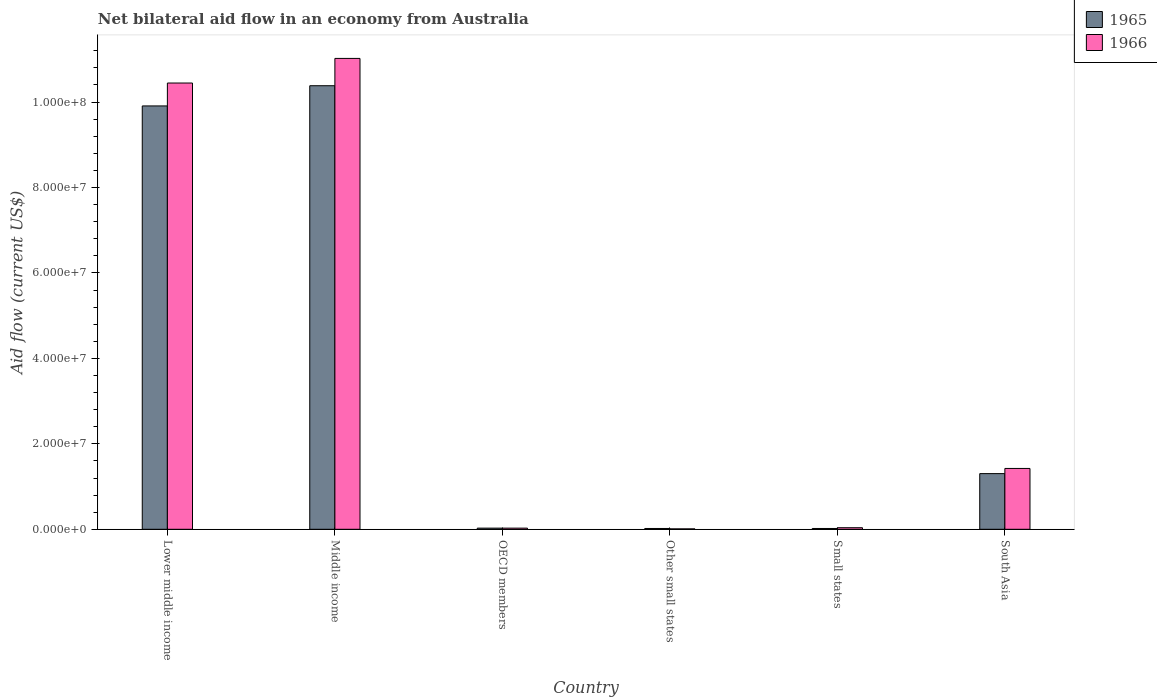How many different coloured bars are there?
Your answer should be compact. 2. How many groups of bars are there?
Provide a short and direct response. 6. Are the number of bars per tick equal to the number of legend labels?
Make the answer very short. Yes. Are the number of bars on each tick of the X-axis equal?
Offer a terse response. Yes. How many bars are there on the 1st tick from the left?
Your answer should be very brief. 2. What is the label of the 3rd group of bars from the left?
Keep it short and to the point. OECD members. What is the net bilateral aid flow in 1965 in Middle income?
Make the answer very short. 1.04e+08. Across all countries, what is the maximum net bilateral aid flow in 1965?
Your response must be concise. 1.04e+08. In which country was the net bilateral aid flow in 1965 minimum?
Provide a succinct answer. Other small states. What is the total net bilateral aid flow in 1966 in the graph?
Make the answer very short. 2.30e+08. What is the difference between the net bilateral aid flow in 1966 in Middle income and the net bilateral aid flow in 1965 in OECD members?
Make the answer very short. 1.10e+08. What is the average net bilateral aid flow in 1966 per country?
Your answer should be compact. 3.83e+07. In how many countries, is the net bilateral aid flow in 1965 greater than 44000000 US$?
Ensure brevity in your answer.  2. What is the ratio of the net bilateral aid flow in 1966 in Lower middle income to that in South Asia?
Your answer should be compact. 7.33. Is the net bilateral aid flow in 1966 in Small states less than that in South Asia?
Ensure brevity in your answer.  Yes. What is the difference between the highest and the second highest net bilateral aid flow in 1965?
Your answer should be very brief. 4.73e+06. What is the difference between the highest and the lowest net bilateral aid flow in 1965?
Offer a very short reply. 1.04e+08. Is the sum of the net bilateral aid flow in 1966 in Middle income and Other small states greater than the maximum net bilateral aid flow in 1965 across all countries?
Your answer should be very brief. Yes. What does the 1st bar from the left in Middle income represents?
Your answer should be compact. 1965. What does the 2nd bar from the right in OECD members represents?
Your response must be concise. 1965. How many bars are there?
Ensure brevity in your answer.  12. Are the values on the major ticks of Y-axis written in scientific E-notation?
Give a very brief answer. Yes. Does the graph contain any zero values?
Make the answer very short. No. Does the graph contain grids?
Your answer should be compact. No. How many legend labels are there?
Your answer should be compact. 2. What is the title of the graph?
Offer a terse response. Net bilateral aid flow in an economy from Australia. Does "1974" appear as one of the legend labels in the graph?
Keep it short and to the point. No. What is the label or title of the X-axis?
Your answer should be very brief. Country. What is the label or title of the Y-axis?
Your response must be concise. Aid flow (current US$). What is the Aid flow (current US$) of 1965 in Lower middle income?
Your answer should be very brief. 9.91e+07. What is the Aid flow (current US$) in 1966 in Lower middle income?
Offer a very short reply. 1.04e+08. What is the Aid flow (current US$) in 1965 in Middle income?
Offer a terse response. 1.04e+08. What is the Aid flow (current US$) of 1966 in Middle income?
Give a very brief answer. 1.10e+08. What is the Aid flow (current US$) of 1965 in Other small states?
Offer a terse response. 1.90e+05. What is the Aid flow (current US$) of 1965 in Small states?
Offer a very short reply. 1.90e+05. What is the Aid flow (current US$) of 1965 in South Asia?
Your response must be concise. 1.30e+07. What is the Aid flow (current US$) in 1966 in South Asia?
Provide a succinct answer. 1.42e+07. Across all countries, what is the maximum Aid flow (current US$) of 1965?
Ensure brevity in your answer.  1.04e+08. Across all countries, what is the maximum Aid flow (current US$) in 1966?
Offer a very short reply. 1.10e+08. What is the total Aid flow (current US$) in 1965 in the graph?
Provide a succinct answer. 2.17e+08. What is the total Aid flow (current US$) in 1966 in the graph?
Ensure brevity in your answer.  2.30e+08. What is the difference between the Aid flow (current US$) in 1965 in Lower middle income and that in Middle income?
Keep it short and to the point. -4.73e+06. What is the difference between the Aid flow (current US$) in 1966 in Lower middle income and that in Middle income?
Offer a terse response. -5.76e+06. What is the difference between the Aid flow (current US$) in 1965 in Lower middle income and that in OECD members?
Ensure brevity in your answer.  9.88e+07. What is the difference between the Aid flow (current US$) of 1966 in Lower middle income and that in OECD members?
Give a very brief answer. 1.04e+08. What is the difference between the Aid flow (current US$) in 1965 in Lower middle income and that in Other small states?
Provide a succinct answer. 9.89e+07. What is the difference between the Aid flow (current US$) of 1966 in Lower middle income and that in Other small states?
Provide a short and direct response. 1.04e+08. What is the difference between the Aid flow (current US$) in 1965 in Lower middle income and that in Small states?
Offer a terse response. 9.89e+07. What is the difference between the Aid flow (current US$) of 1966 in Lower middle income and that in Small states?
Keep it short and to the point. 1.04e+08. What is the difference between the Aid flow (current US$) of 1965 in Lower middle income and that in South Asia?
Offer a very short reply. 8.61e+07. What is the difference between the Aid flow (current US$) of 1966 in Lower middle income and that in South Asia?
Your response must be concise. 9.02e+07. What is the difference between the Aid flow (current US$) of 1965 in Middle income and that in OECD members?
Your answer should be very brief. 1.04e+08. What is the difference between the Aid flow (current US$) of 1966 in Middle income and that in OECD members?
Offer a terse response. 1.10e+08. What is the difference between the Aid flow (current US$) in 1965 in Middle income and that in Other small states?
Your answer should be compact. 1.04e+08. What is the difference between the Aid flow (current US$) of 1966 in Middle income and that in Other small states?
Provide a succinct answer. 1.10e+08. What is the difference between the Aid flow (current US$) of 1965 in Middle income and that in Small states?
Provide a short and direct response. 1.04e+08. What is the difference between the Aid flow (current US$) in 1966 in Middle income and that in Small states?
Make the answer very short. 1.10e+08. What is the difference between the Aid flow (current US$) in 1965 in Middle income and that in South Asia?
Ensure brevity in your answer.  9.08e+07. What is the difference between the Aid flow (current US$) in 1966 in Middle income and that in South Asia?
Keep it short and to the point. 9.60e+07. What is the difference between the Aid flow (current US$) in 1965 in OECD members and that in Other small states?
Keep it short and to the point. 8.00e+04. What is the difference between the Aid flow (current US$) of 1965 in OECD members and that in Small states?
Your answer should be very brief. 8.00e+04. What is the difference between the Aid flow (current US$) of 1966 in OECD members and that in Small states?
Keep it short and to the point. -1.00e+05. What is the difference between the Aid flow (current US$) of 1965 in OECD members and that in South Asia?
Your answer should be compact. -1.28e+07. What is the difference between the Aid flow (current US$) in 1966 in OECD members and that in South Asia?
Offer a very short reply. -1.40e+07. What is the difference between the Aid flow (current US$) in 1965 in Other small states and that in Small states?
Your response must be concise. 0. What is the difference between the Aid flow (current US$) in 1966 in Other small states and that in Small states?
Make the answer very short. -2.70e+05. What is the difference between the Aid flow (current US$) in 1965 in Other small states and that in South Asia?
Provide a succinct answer. -1.28e+07. What is the difference between the Aid flow (current US$) of 1966 in Other small states and that in South Asia?
Your response must be concise. -1.41e+07. What is the difference between the Aid flow (current US$) of 1965 in Small states and that in South Asia?
Your response must be concise. -1.28e+07. What is the difference between the Aid flow (current US$) in 1966 in Small states and that in South Asia?
Keep it short and to the point. -1.39e+07. What is the difference between the Aid flow (current US$) of 1965 in Lower middle income and the Aid flow (current US$) of 1966 in Middle income?
Make the answer very short. -1.11e+07. What is the difference between the Aid flow (current US$) in 1965 in Lower middle income and the Aid flow (current US$) in 1966 in OECD members?
Give a very brief answer. 9.88e+07. What is the difference between the Aid flow (current US$) in 1965 in Lower middle income and the Aid flow (current US$) in 1966 in Other small states?
Offer a terse response. 9.90e+07. What is the difference between the Aid flow (current US$) of 1965 in Lower middle income and the Aid flow (current US$) of 1966 in Small states?
Your answer should be very brief. 9.87e+07. What is the difference between the Aid flow (current US$) of 1965 in Lower middle income and the Aid flow (current US$) of 1966 in South Asia?
Ensure brevity in your answer.  8.48e+07. What is the difference between the Aid flow (current US$) in 1965 in Middle income and the Aid flow (current US$) in 1966 in OECD members?
Provide a succinct answer. 1.04e+08. What is the difference between the Aid flow (current US$) in 1965 in Middle income and the Aid flow (current US$) in 1966 in Other small states?
Provide a succinct answer. 1.04e+08. What is the difference between the Aid flow (current US$) of 1965 in Middle income and the Aid flow (current US$) of 1966 in Small states?
Keep it short and to the point. 1.03e+08. What is the difference between the Aid flow (current US$) of 1965 in Middle income and the Aid flow (current US$) of 1966 in South Asia?
Make the answer very short. 8.96e+07. What is the difference between the Aid flow (current US$) of 1965 in OECD members and the Aid flow (current US$) of 1966 in Small states?
Give a very brief answer. -1.00e+05. What is the difference between the Aid flow (current US$) in 1965 in OECD members and the Aid flow (current US$) in 1966 in South Asia?
Give a very brief answer. -1.40e+07. What is the difference between the Aid flow (current US$) of 1965 in Other small states and the Aid flow (current US$) of 1966 in Small states?
Your answer should be compact. -1.80e+05. What is the difference between the Aid flow (current US$) of 1965 in Other small states and the Aid flow (current US$) of 1966 in South Asia?
Offer a very short reply. -1.40e+07. What is the difference between the Aid flow (current US$) in 1965 in Small states and the Aid flow (current US$) in 1966 in South Asia?
Ensure brevity in your answer.  -1.40e+07. What is the average Aid flow (current US$) of 1965 per country?
Provide a succinct answer. 3.61e+07. What is the average Aid flow (current US$) in 1966 per country?
Ensure brevity in your answer.  3.83e+07. What is the difference between the Aid flow (current US$) of 1965 and Aid flow (current US$) of 1966 in Lower middle income?
Offer a very short reply. -5.36e+06. What is the difference between the Aid flow (current US$) in 1965 and Aid flow (current US$) in 1966 in Middle income?
Keep it short and to the point. -6.39e+06. What is the difference between the Aid flow (current US$) of 1965 and Aid flow (current US$) of 1966 in OECD members?
Offer a very short reply. 0. What is the difference between the Aid flow (current US$) of 1965 and Aid flow (current US$) of 1966 in Other small states?
Keep it short and to the point. 9.00e+04. What is the difference between the Aid flow (current US$) of 1965 and Aid flow (current US$) of 1966 in South Asia?
Give a very brief answer. -1.21e+06. What is the ratio of the Aid flow (current US$) of 1965 in Lower middle income to that in Middle income?
Make the answer very short. 0.95. What is the ratio of the Aid flow (current US$) in 1966 in Lower middle income to that in Middle income?
Keep it short and to the point. 0.95. What is the ratio of the Aid flow (current US$) in 1965 in Lower middle income to that in OECD members?
Provide a short and direct response. 367. What is the ratio of the Aid flow (current US$) in 1966 in Lower middle income to that in OECD members?
Offer a terse response. 386.85. What is the ratio of the Aid flow (current US$) in 1965 in Lower middle income to that in Other small states?
Offer a very short reply. 521.53. What is the ratio of the Aid flow (current US$) of 1966 in Lower middle income to that in Other small states?
Provide a succinct answer. 1044.5. What is the ratio of the Aid flow (current US$) of 1965 in Lower middle income to that in Small states?
Your answer should be compact. 521.53. What is the ratio of the Aid flow (current US$) of 1966 in Lower middle income to that in Small states?
Your answer should be very brief. 282.3. What is the ratio of the Aid flow (current US$) of 1965 in Lower middle income to that in South Asia?
Ensure brevity in your answer.  7.6. What is the ratio of the Aid flow (current US$) in 1966 in Lower middle income to that in South Asia?
Provide a short and direct response. 7.33. What is the ratio of the Aid flow (current US$) of 1965 in Middle income to that in OECD members?
Provide a short and direct response. 384.52. What is the ratio of the Aid flow (current US$) of 1966 in Middle income to that in OECD members?
Your response must be concise. 408.19. What is the ratio of the Aid flow (current US$) of 1965 in Middle income to that in Other small states?
Offer a very short reply. 546.42. What is the ratio of the Aid flow (current US$) in 1966 in Middle income to that in Other small states?
Provide a succinct answer. 1102.1. What is the ratio of the Aid flow (current US$) in 1965 in Middle income to that in Small states?
Offer a very short reply. 546.42. What is the ratio of the Aid flow (current US$) of 1966 in Middle income to that in Small states?
Provide a succinct answer. 297.86. What is the ratio of the Aid flow (current US$) of 1965 in Middle income to that in South Asia?
Your response must be concise. 7.97. What is the ratio of the Aid flow (current US$) in 1966 in Middle income to that in South Asia?
Provide a succinct answer. 7.74. What is the ratio of the Aid flow (current US$) in 1965 in OECD members to that in Other small states?
Give a very brief answer. 1.42. What is the ratio of the Aid flow (current US$) of 1965 in OECD members to that in Small states?
Your answer should be very brief. 1.42. What is the ratio of the Aid flow (current US$) of 1966 in OECD members to that in Small states?
Provide a short and direct response. 0.73. What is the ratio of the Aid flow (current US$) of 1965 in OECD members to that in South Asia?
Your response must be concise. 0.02. What is the ratio of the Aid flow (current US$) of 1966 in OECD members to that in South Asia?
Keep it short and to the point. 0.02. What is the ratio of the Aid flow (current US$) of 1965 in Other small states to that in Small states?
Keep it short and to the point. 1. What is the ratio of the Aid flow (current US$) in 1966 in Other small states to that in Small states?
Keep it short and to the point. 0.27. What is the ratio of the Aid flow (current US$) of 1965 in Other small states to that in South Asia?
Make the answer very short. 0.01. What is the ratio of the Aid flow (current US$) in 1966 in Other small states to that in South Asia?
Your answer should be very brief. 0.01. What is the ratio of the Aid flow (current US$) in 1965 in Small states to that in South Asia?
Give a very brief answer. 0.01. What is the ratio of the Aid flow (current US$) in 1966 in Small states to that in South Asia?
Give a very brief answer. 0.03. What is the difference between the highest and the second highest Aid flow (current US$) in 1965?
Provide a succinct answer. 4.73e+06. What is the difference between the highest and the second highest Aid flow (current US$) in 1966?
Your answer should be very brief. 5.76e+06. What is the difference between the highest and the lowest Aid flow (current US$) of 1965?
Make the answer very short. 1.04e+08. What is the difference between the highest and the lowest Aid flow (current US$) in 1966?
Keep it short and to the point. 1.10e+08. 